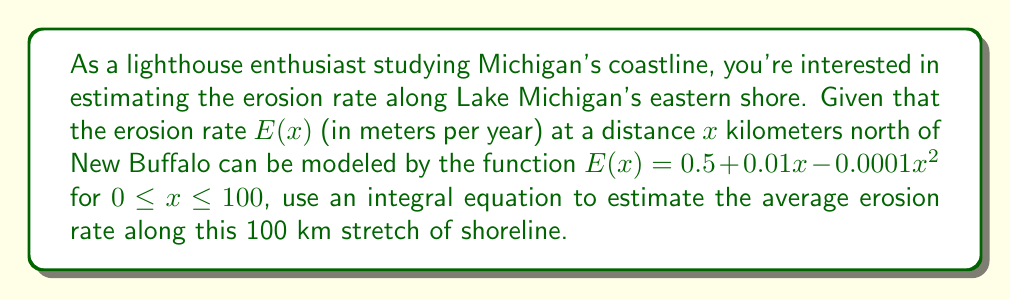Could you help me with this problem? To solve this problem, we'll follow these steps:

1) The average erosion rate can be calculated using the definite integral of the erosion function divided by the length of the shoreline.

2) Set up the integral equation:

   Average Erosion Rate = $\frac{1}{b-a} \int_{a}^{b} E(x) dx$

   where $a = 0$ and $b = 100$ (the range of $x$ in km)

3) Substitute the given function:

   $\frac{1}{100-0} \int_{0}^{100} (0.5 + 0.01x - 0.0001x^2) dx$

4) Simplify:

   $\frac{1}{100} \int_{0}^{100} (0.5 + 0.01x - 0.0001x^2) dx$

5) Integrate:

   $\frac{1}{100} [0.5x + 0.005x^2 - \frac{0.0001}{3}x^3]_{0}^{100}$

6) Evaluate the integral:

   $\frac{1}{100} [(0.5(100) + 0.005(100^2) - \frac{0.0001}{3}(100^3)) - (0.5(0) + 0.005(0^2) - \frac{0.0001}{3}(0^3))]$

7) Simplify:

   $\frac{1}{100} [50 + 50 - \frac{100}{3}]$

8) Calculate:

   $\frac{1}{100} [\frac{150 - 100/3}{1}] = \frac{150 - 100/3}{100} = 1.1666...$

Therefore, the average erosion rate is approximately 1.17 meters per year.
Answer: 1.17 m/year 